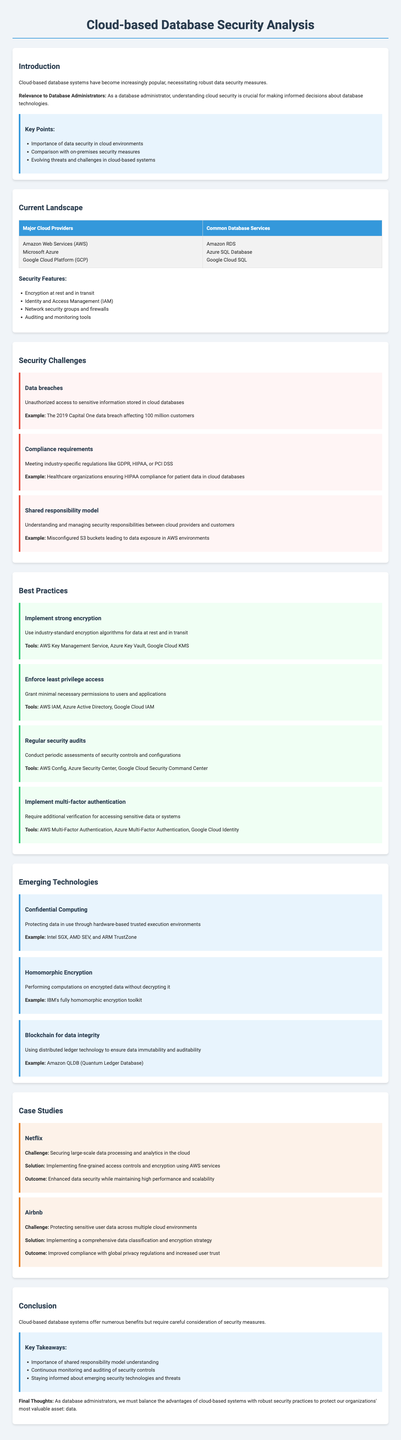What are the major cloud providers mentioned? The section lists three prominent cloud providers for cloud-based databases.
Answer: Amazon Web Services, Microsoft Azure, Google Cloud Platform What is one example of a data security challenge? The document outlines several challenges regarding data security in cloud-based systems, providing specific instances.
Answer: Data breaches Which database service is associated with AWS? The report discusses common database services for major cloud providers, listing specific services related to AWS.
Answer: Amazon RDS What technology focuses on protecting data in use? The emerging technologies section describes various innovations, specifically mentioning one that secures data during processing.
Answer: Confidential Computing What is one of the best practices for cloud data security? The report provides a list of recommended practices for ensuring better data security in cloud databases.
Answer: Implement strong encryption 